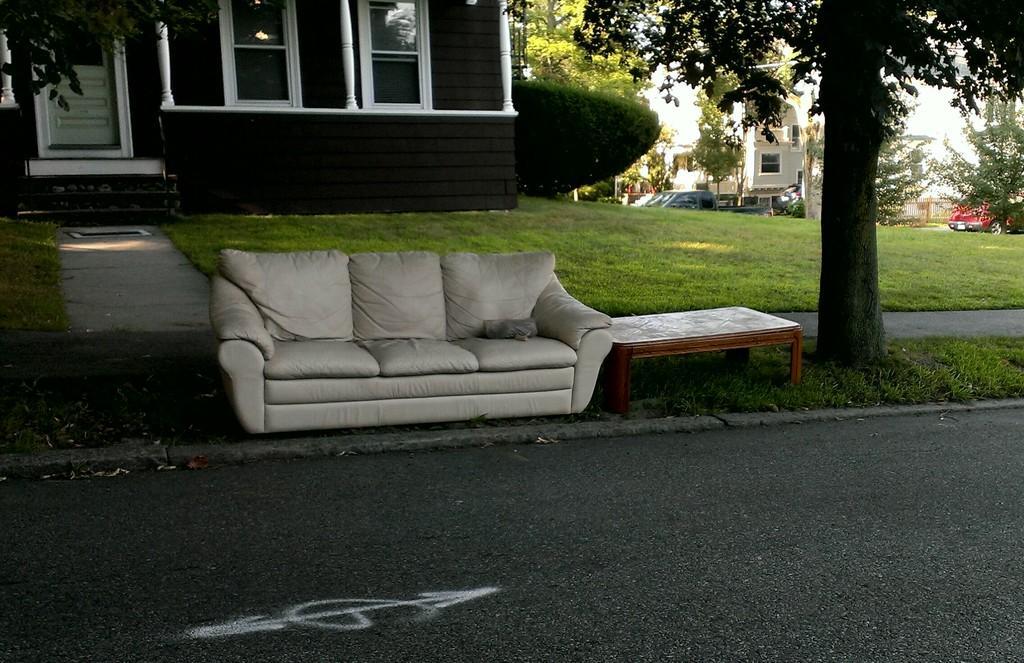Can you describe this image briefly? A sofa and a table are placed beside a road in front of a house. 